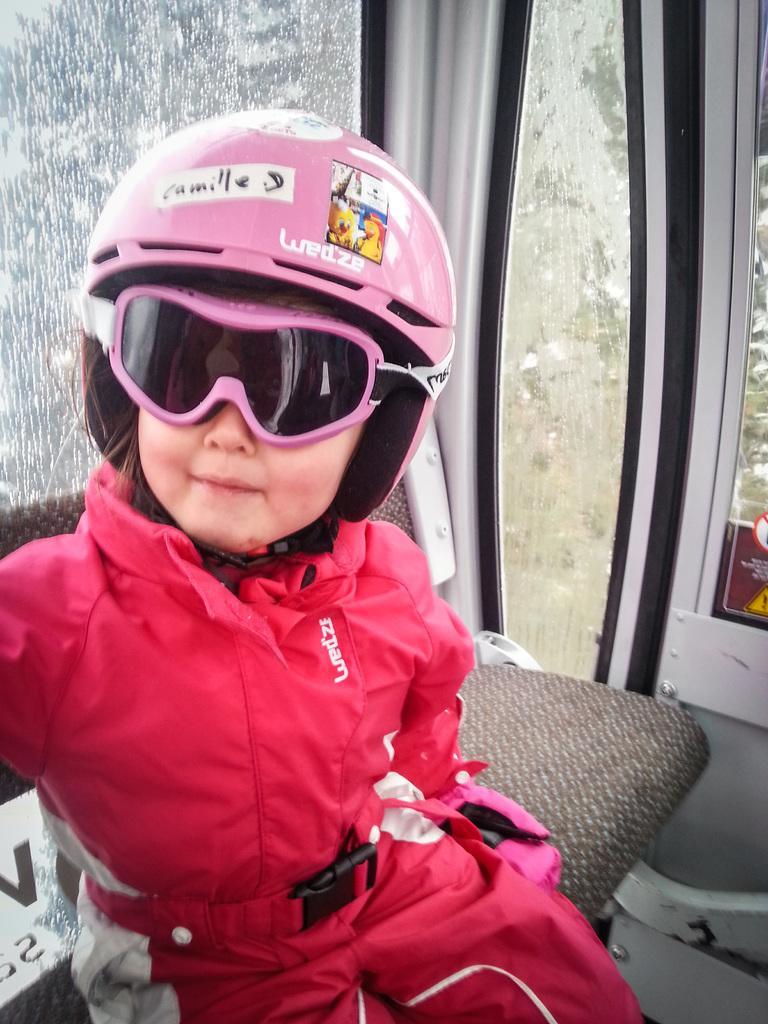Could you give a brief overview of what you see in this image? In this image I can see a girl and I can see she is wearing pink dress, pink shades and pink helmet. I can also see something is written on his helmet. 